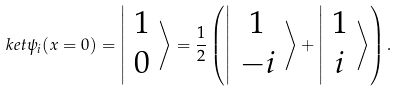<formula> <loc_0><loc_0><loc_500><loc_500>\ k e t { \psi _ { i } ( x = 0 ) } = \left | \begin{array} { c } 1 \\ 0 \end{array} \right \rangle = \frac { 1 } { 2 } \left ( \left | \begin{array} { c } 1 \\ - i \end{array} \right \rangle + \left | \begin{array} { c } 1 \\ i \end{array} \right \rangle \right ) .</formula> 